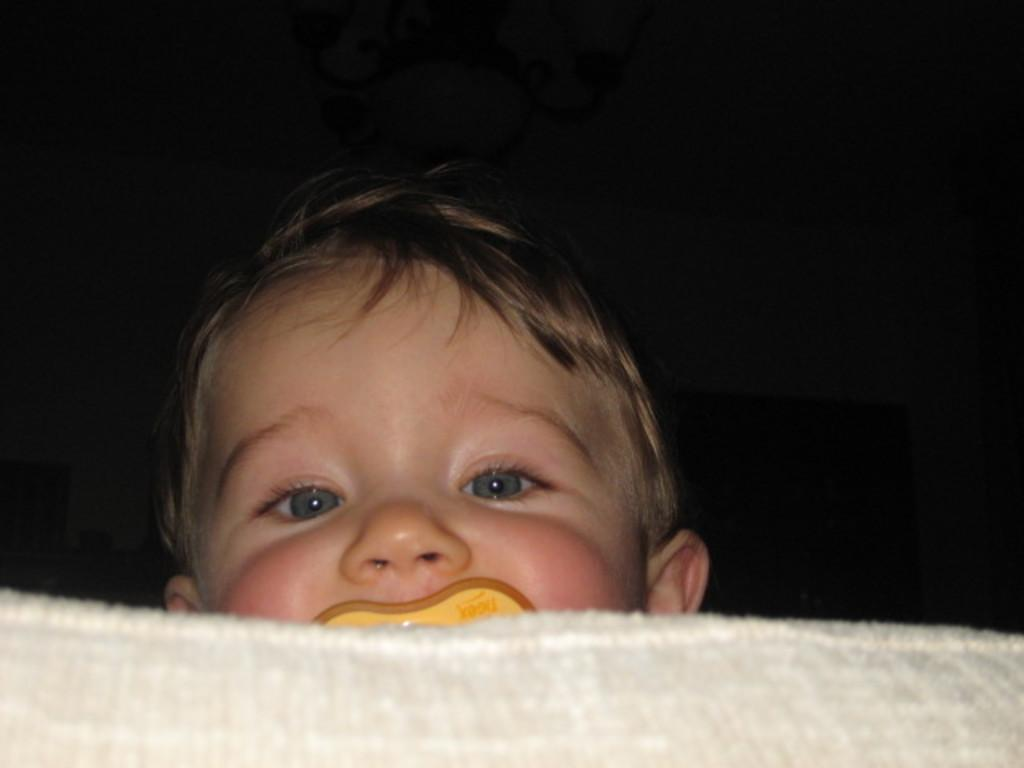What is at the bottom of the image? There is a white cloth at the bottom of the image. What might the white cloth be used for? The white cloth appears to be a bed. Where is the baby located in the image? The baby is behind the bed. What is the color of the background in the image? The background of the image is in black color. What type of cough medicine is the baby taking in the image? There is no indication of a cough or medicine in the image; it only shows a baby behind a bed with a black background. 